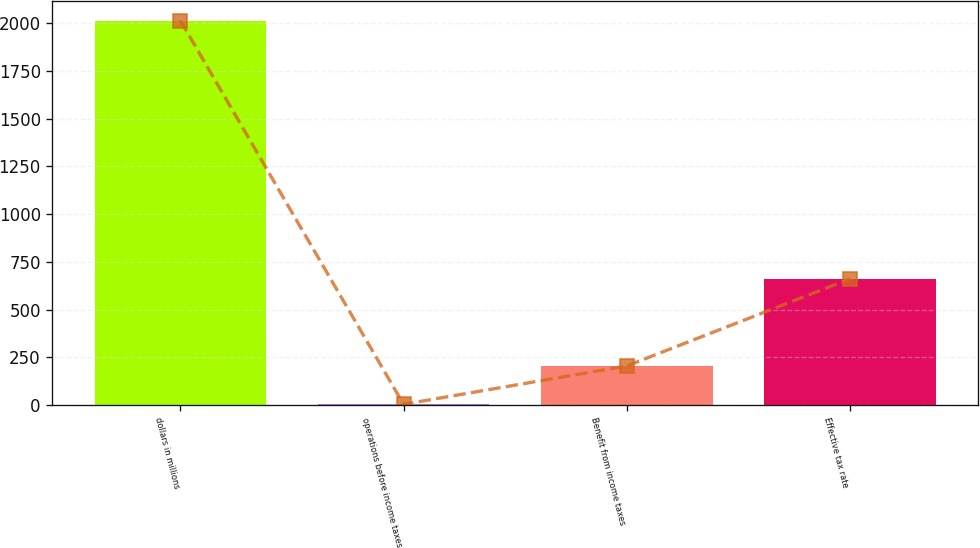<chart> <loc_0><loc_0><loc_500><loc_500><bar_chart><fcel>dollars in millions<fcel>operations before income taxes<fcel>Benefit from income taxes<fcel>Effective tax rate<nl><fcel>2013<fcel>3.7<fcel>204.63<fcel>660.5<nl></chart> 